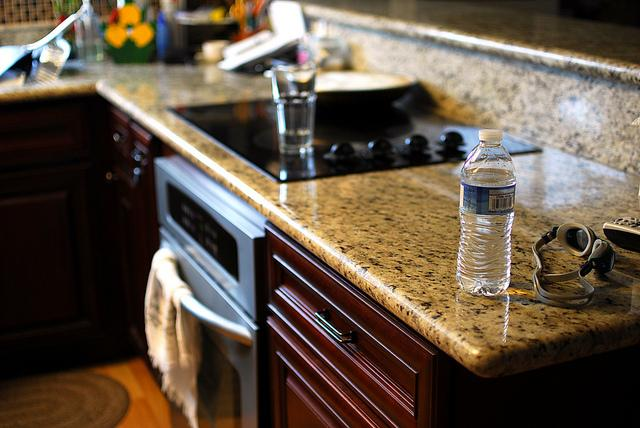The item next to the water bottle is usually used in what setting? Please explain your reasoning. pool. The item next to the water bottle are goggles used for swimming. 